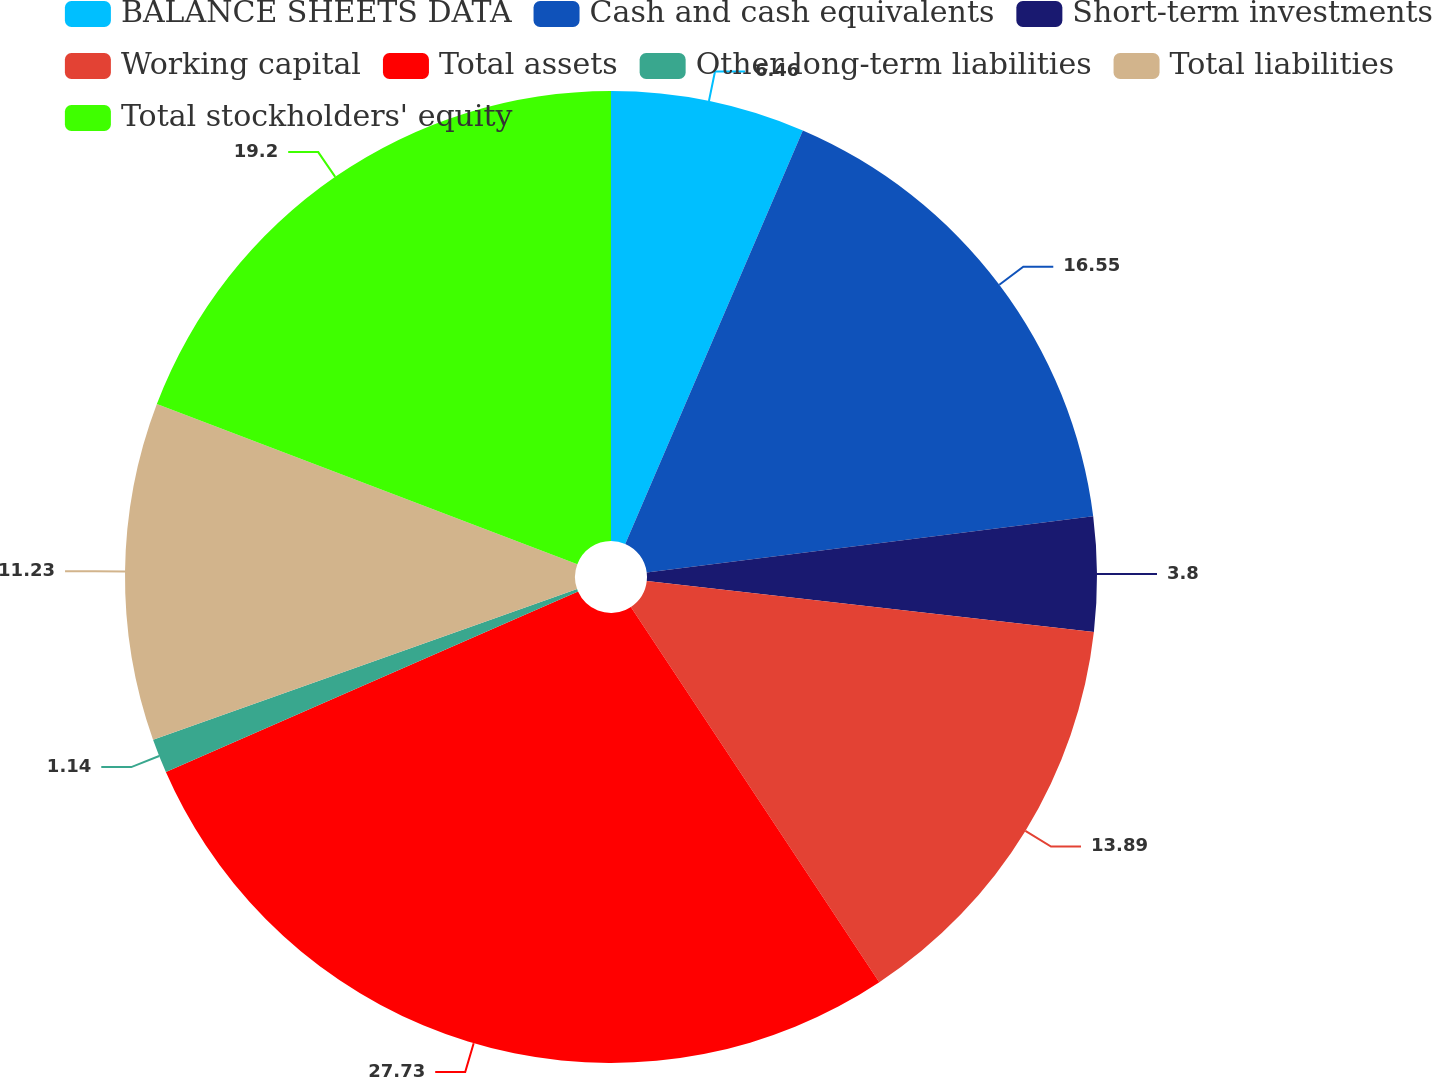Convert chart. <chart><loc_0><loc_0><loc_500><loc_500><pie_chart><fcel>BALANCE SHEETS DATA<fcel>Cash and cash equivalents<fcel>Short-term investments<fcel>Working capital<fcel>Total assets<fcel>Other long-term liabilities<fcel>Total liabilities<fcel>Total stockholders' equity<nl><fcel>6.46%<fcel>16.55%<fcel>3.8%<fcel>13.89%<fcel>27.74%<fcel>1.14%<fcel>11.23%<fcel>19.21%<nl></chart> 